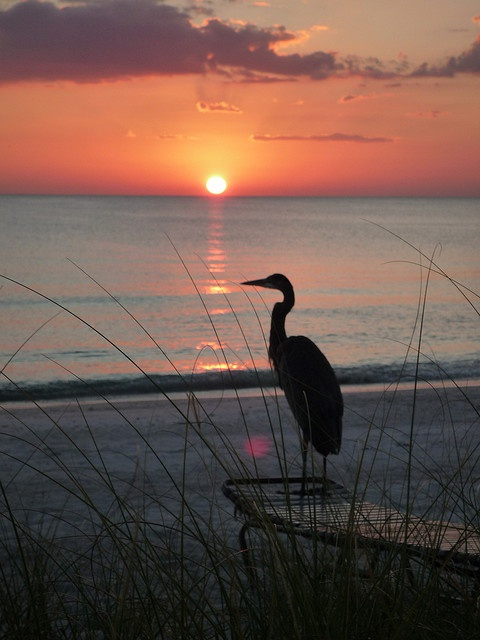Describe the objects in this image and their specific colors. I can see a bird in gray and black tones in this image. 